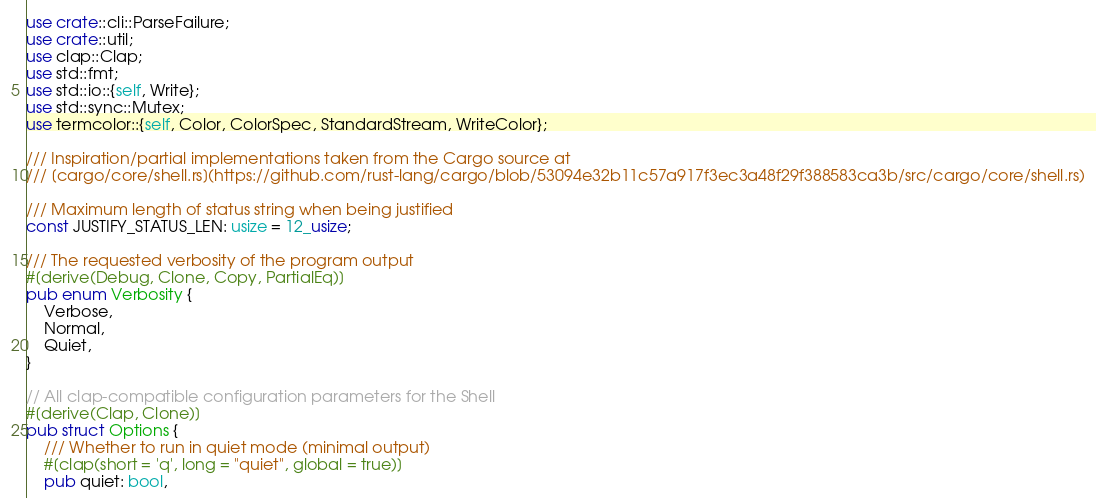<code> <loc_0><loc_0><loc_500><loc_500><_Rust_>use crate::cli::ParseFailure;
use crate::util;
use clap::Clap;
use std::fmt;
use std::io::{self, Write};
use std::sync::Mutex;
use termcolor::{self, Color, ColorSpec, StandardStream, WriteColor};

/// Inspiration/partial implementations taken from the Cargo source at
/// [cargo/core/shell.rs](https://github.com/rust-lang/cargo/blob/53094e32b11c57a917f3ec3a48f29f388583ca3b/src/cargo/core/shell.rs)

/// Maximum length of status string when being justified
const JUSTIFY_STATUS_LEN: usize = 12_usize;

/// The requested verbosity of the program output
#[derive(Debug, Clone, Copy, PartialEq)]
pub enum Verbosity {
    Verbose,
    Normal,
    Quiet,
}

// All clap-compatible configuration parameters for the Shell
#[derive(Clap, Clone)]
pub struct Options {
    /// Whether to run in quiet mode (minimal output)
    #[clap(short = 'q', long = "quiet", global = true)]
    pub quiet: bool,
</code> 